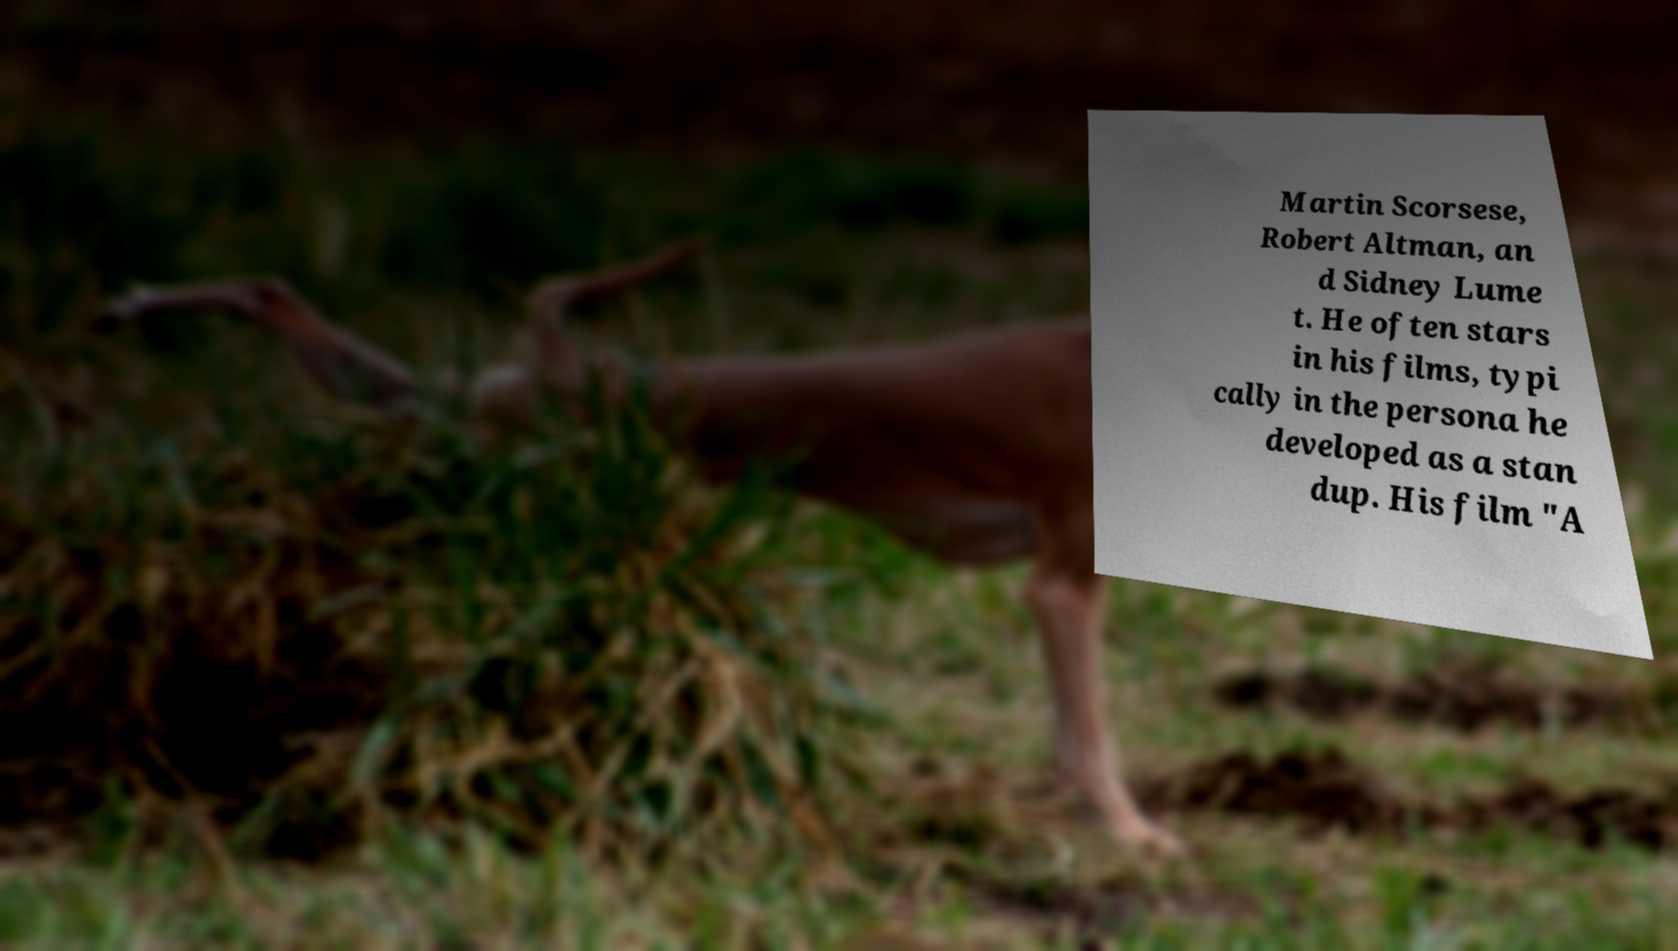Could you assist in decoding the text presented in this image and type it out clearly? Martin Scorsese, Robert Altman, an d Sidney Lume t. He often stars in his films, typi cally in the persona he developed as a stan dup. His film "A 